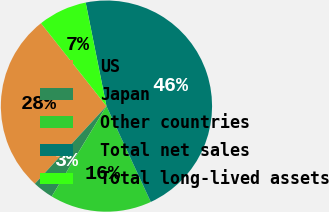Convert chart to OTSL. <chart><loc_0><loc_0><loc_500><loc_500><pie_chart><fcel>US<fcel>Japan<fcel>Other countries<fcel>Total net sales<fcel>Total long-lived assets<nl><fcel>27.51%<fcel>3.18%<fcel>15.57%<fcel>46.26%<fcel>7.49%<nl></chart> 